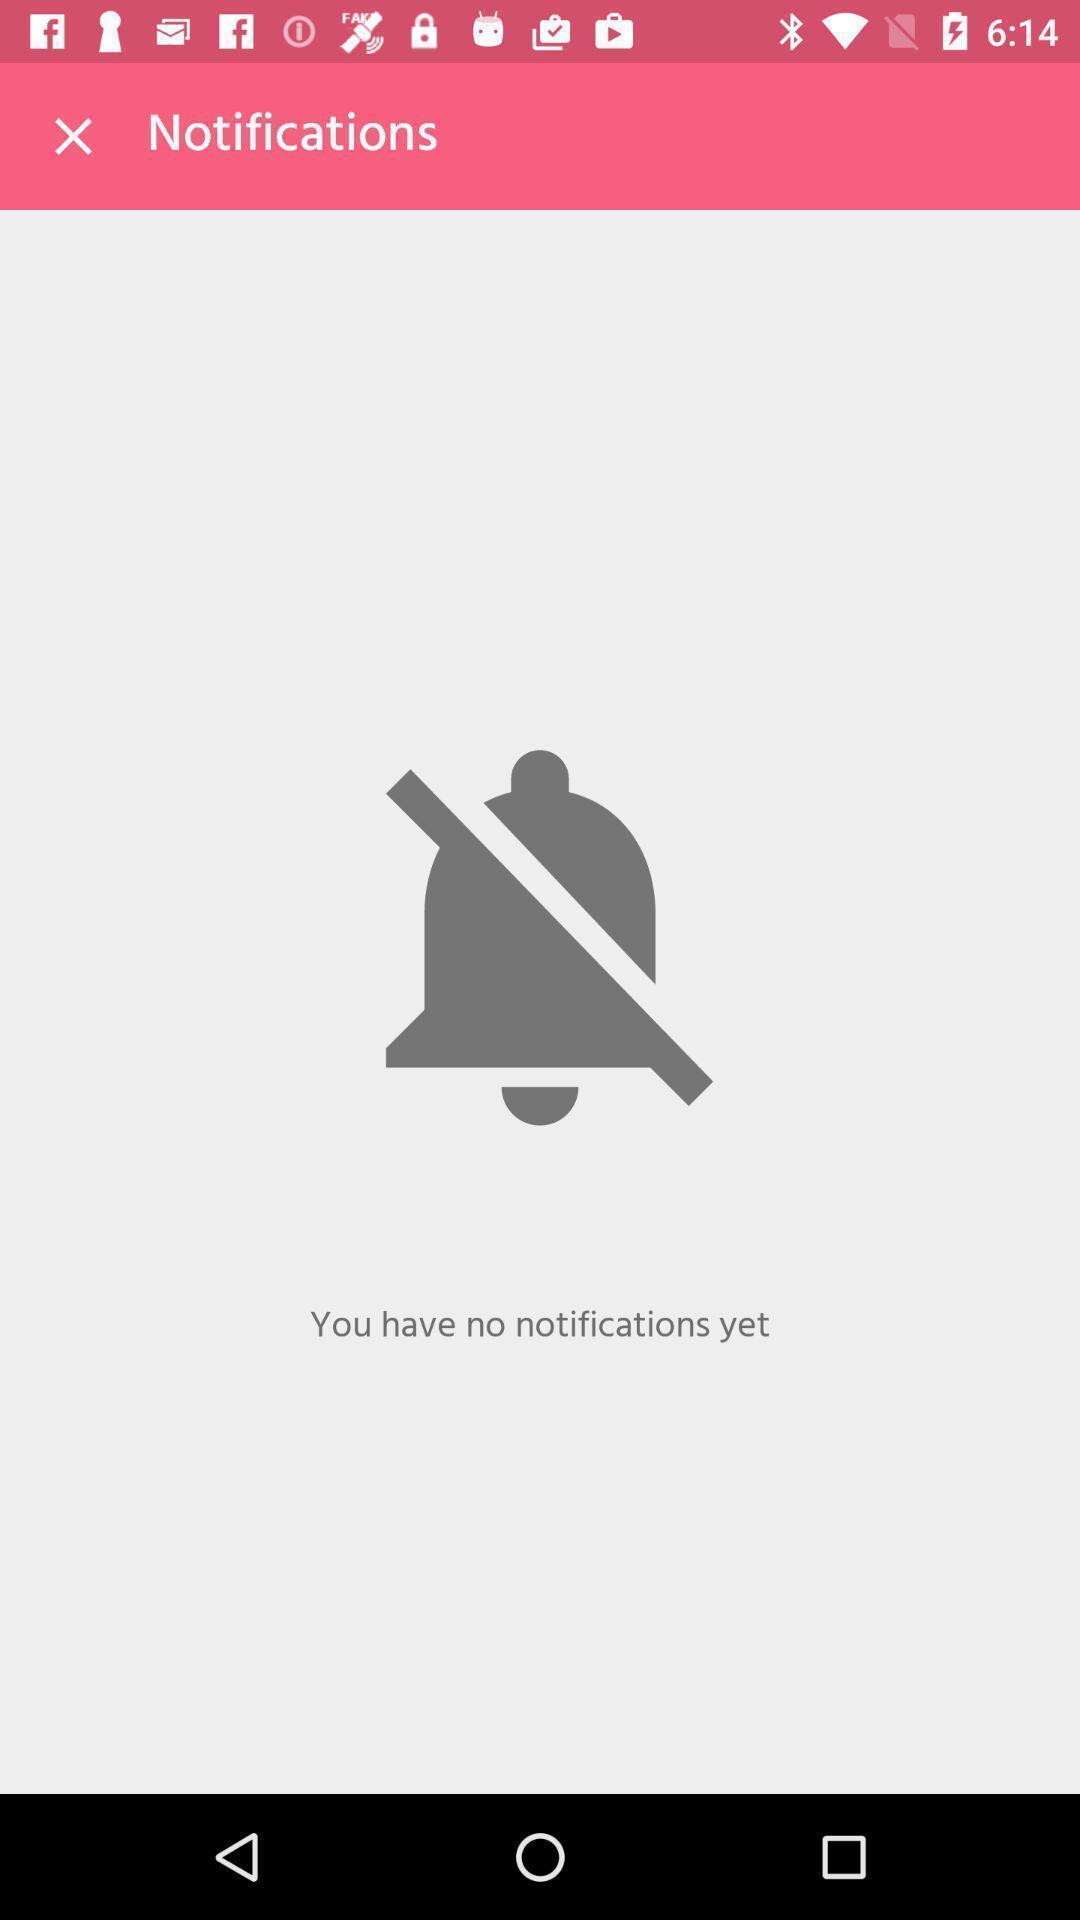Describe the key features of this screenshot. Page shows the notifications on baby growth app. 